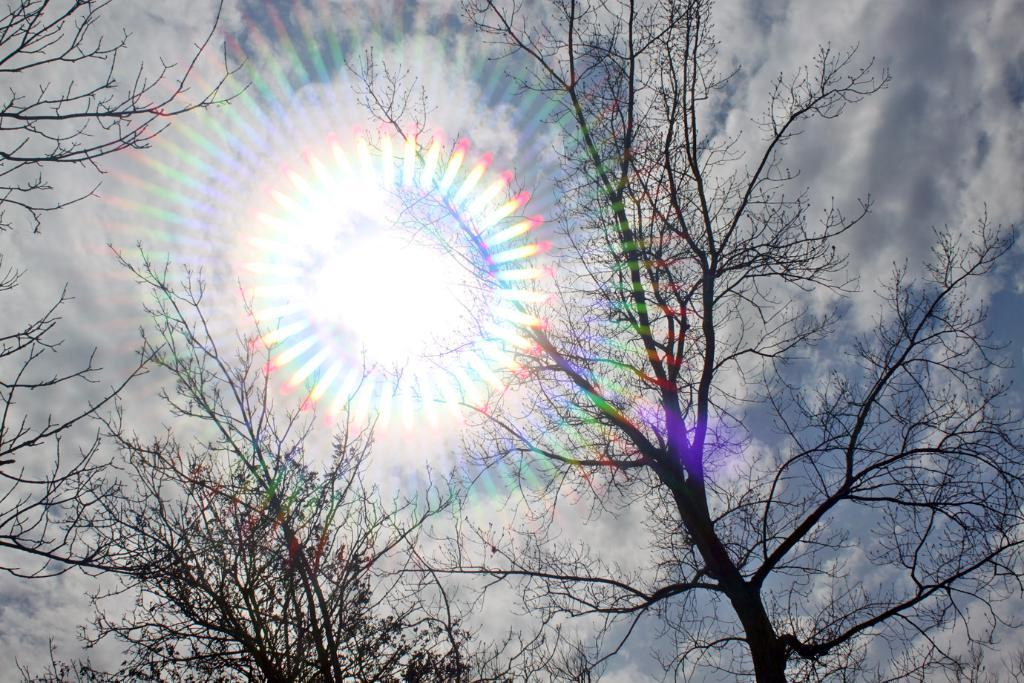What type of vegetation can be seen in the image? There are trees in the image. What celestial body is visible in the sky? The sun is visible in the sky. What type of wine is being served on the sheet in the image? There is no wine or sheet present in the image; it only features trees and the sun in the sky. 